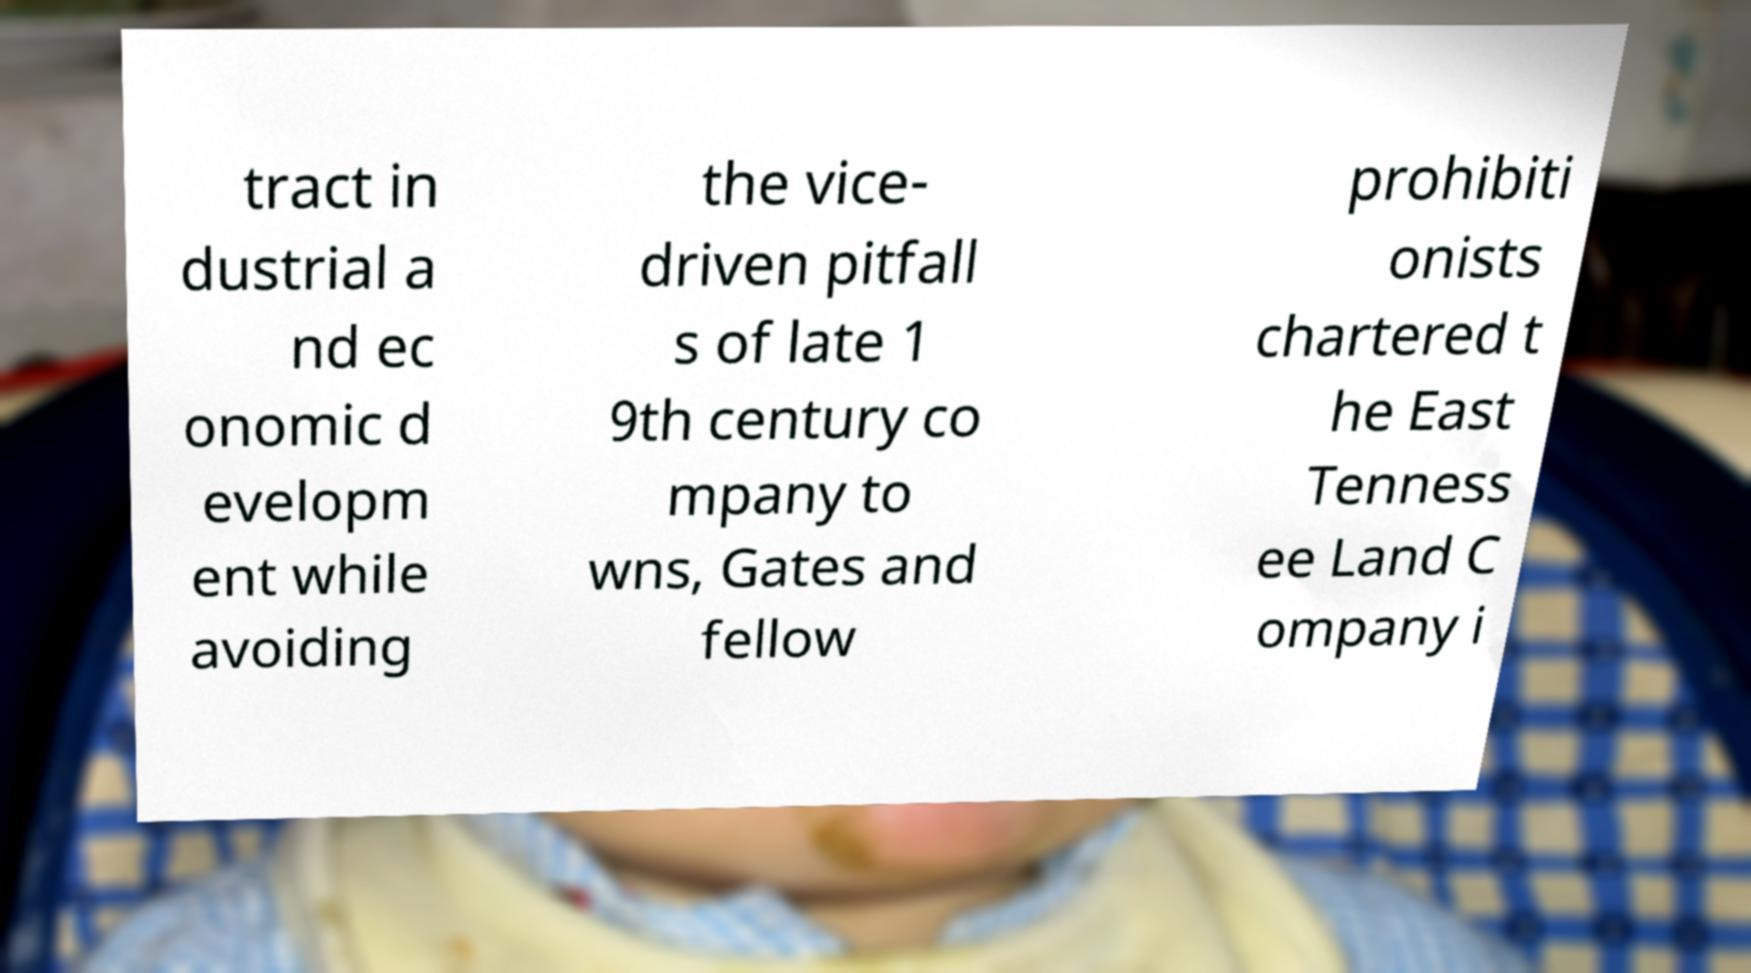For documentation purposes, I need the text within this image transcribed. Could you provide that? tract in dustrial a nd ec onomic d evelopm ent while avoiding the vice- driven pitfall s of late 1 9th century co mpany to wns, Gates and fellow prohibiti onists chartered t he East Tenness ee Land C ompany i 